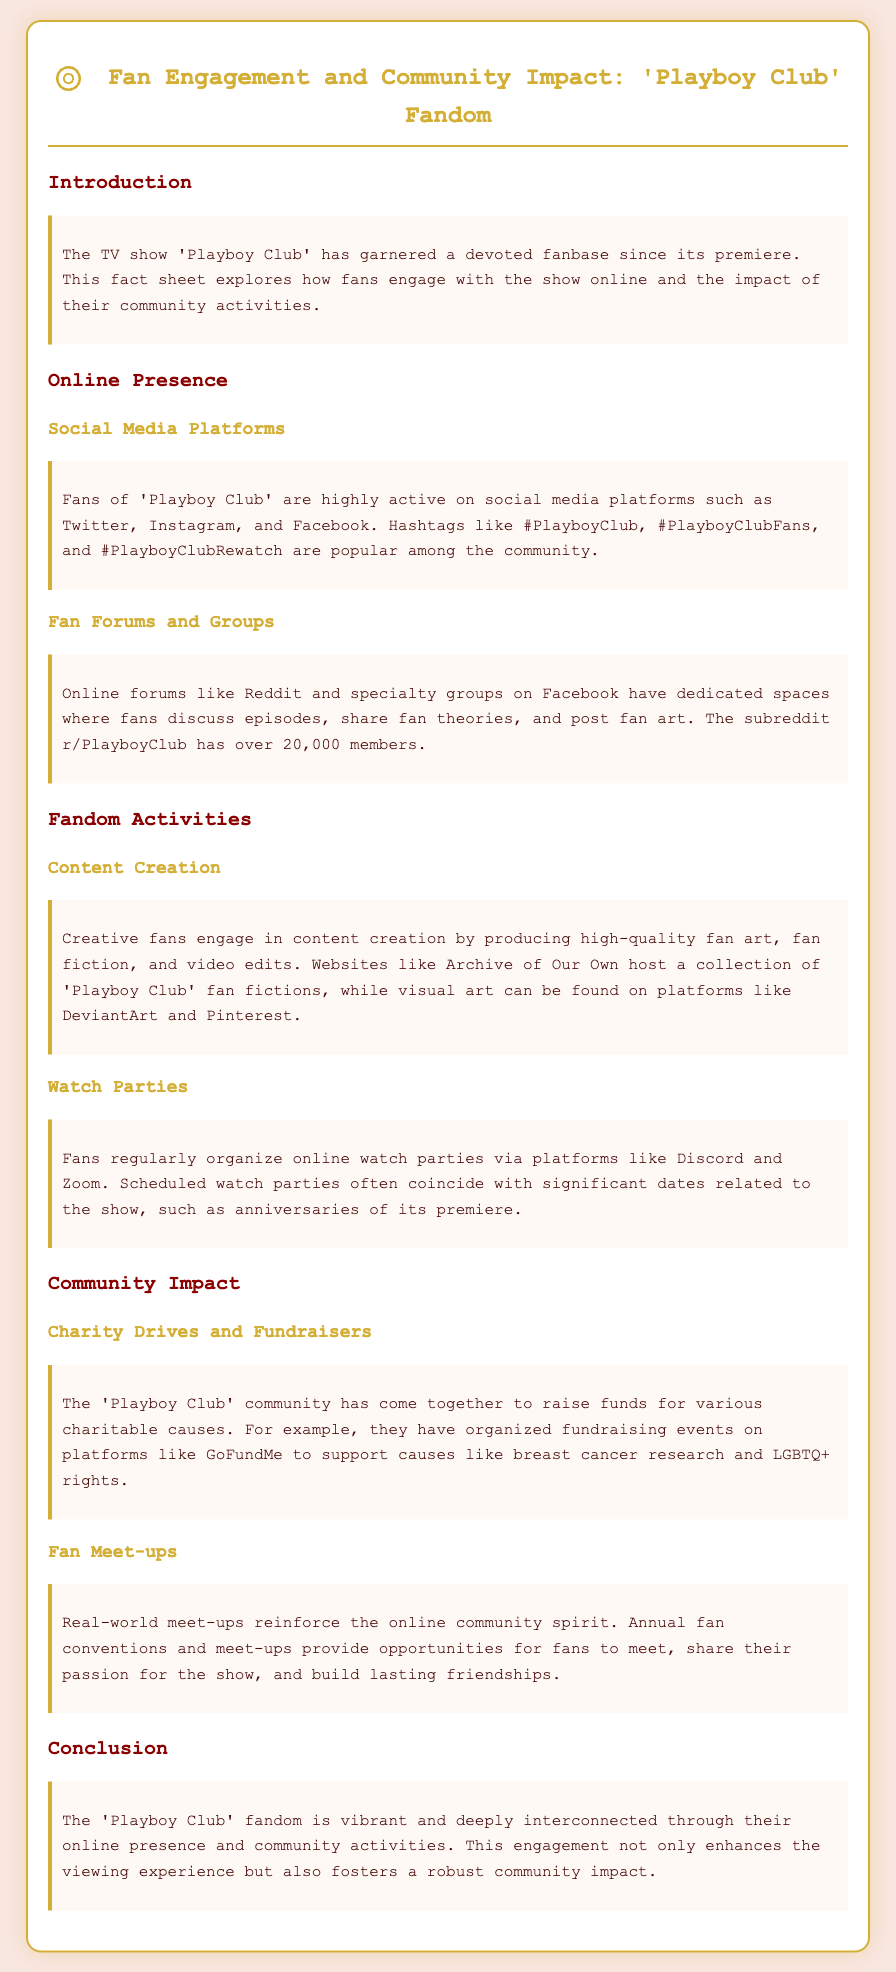What is the subreddit dedicated to 'Playboy Club'? The subreddit specifically mentioned for 'Playboy Club' is where fans discuss episodes and share content, which has over 20,000 members.
Answer: r/PlayboyClub How many social media platforms are mentioned where fans are active? The document states that fans are active on multiple platforms, specifically listing Twitter, Instagram, and Facebook.
Answer: Three What type of events have the 'Playboy Club' community organized to support charitable causes? The document indicates fundraising activities for various charitable causes have been organized on platforms like GoFundMe.
Answer: Fundraising events What visual art platforms are mentioned for 'Playboy Club' fan creations? The document discusses where fans create and share visual art related to the show, naming specific platforms for art.
Answer: DeviantArt and Pinterest What is the focus of the community impact section in the fact sheet? The document addresses how fans engage in real-world activities that reflect their online community values and efforts.
Answer: Charity Drives and Fan Meet-ups How often do fans organize online watch parties? The type of activity includes regular organization, often reflecting significant dates associated with the show.
Answer: Regularly What color is the background of the document styled as? The background color of the fact sheet is described in the document, reflecting the overall theme of the page.
Answer: Light pink 